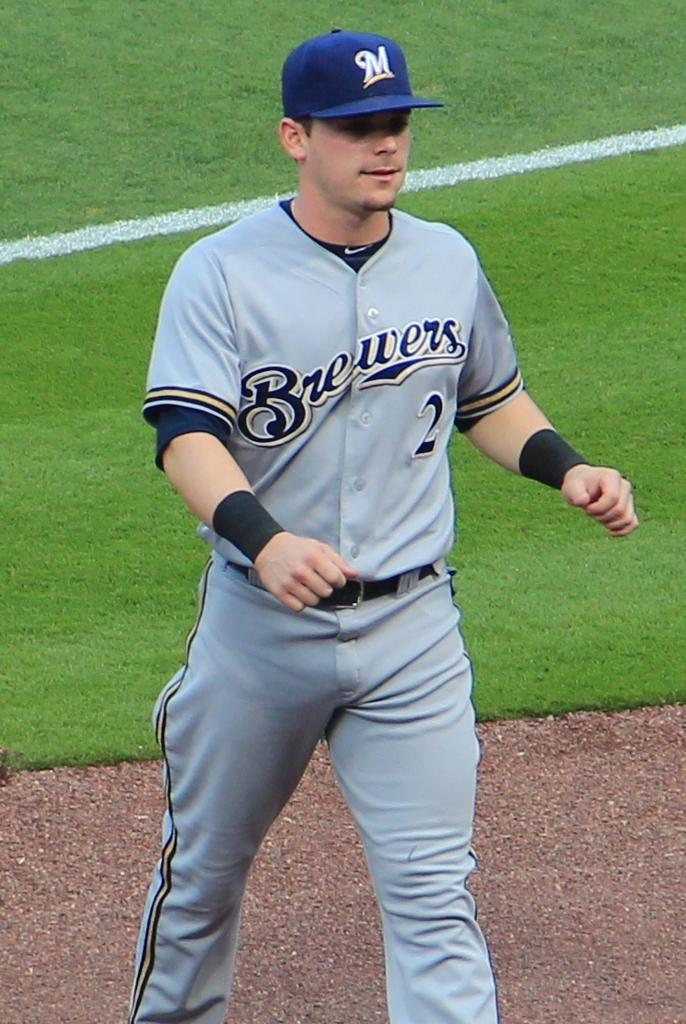<image>
Offer a succinct explanation of the picture presented. A baseball player for the Brewers is walking off the baseball field. 